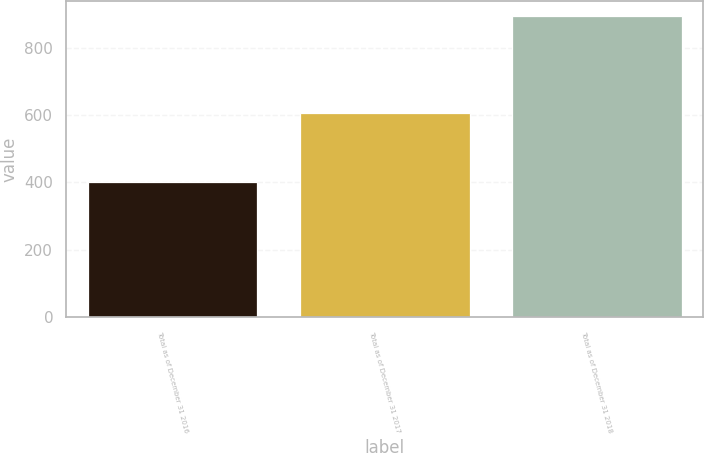<chart> <loc_0><loc_0><loc_500><loc_500><bar_chart><fcel>Total as of December 31 2016<fcel>Total as of December 31 2017<fcel>Total as of December 31 2018<nl><fcel>401<fcel>605<fcel>894<nl></chart> 